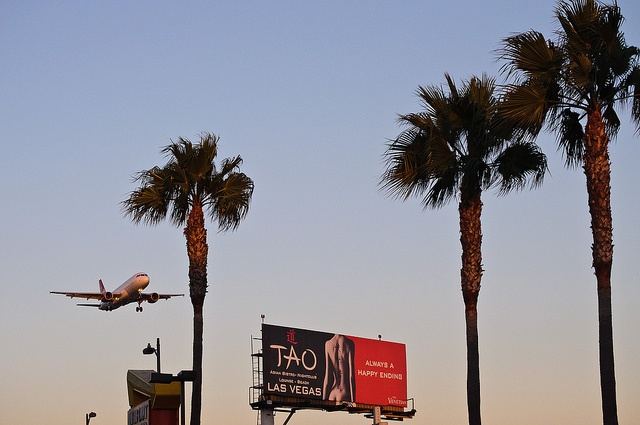Describe the objects in this image and their specific colors. I can see people in darkgray, black, brown, maroon, and salmon tones and airplane in darkgray, black, maroon, and brown tones in this image. 